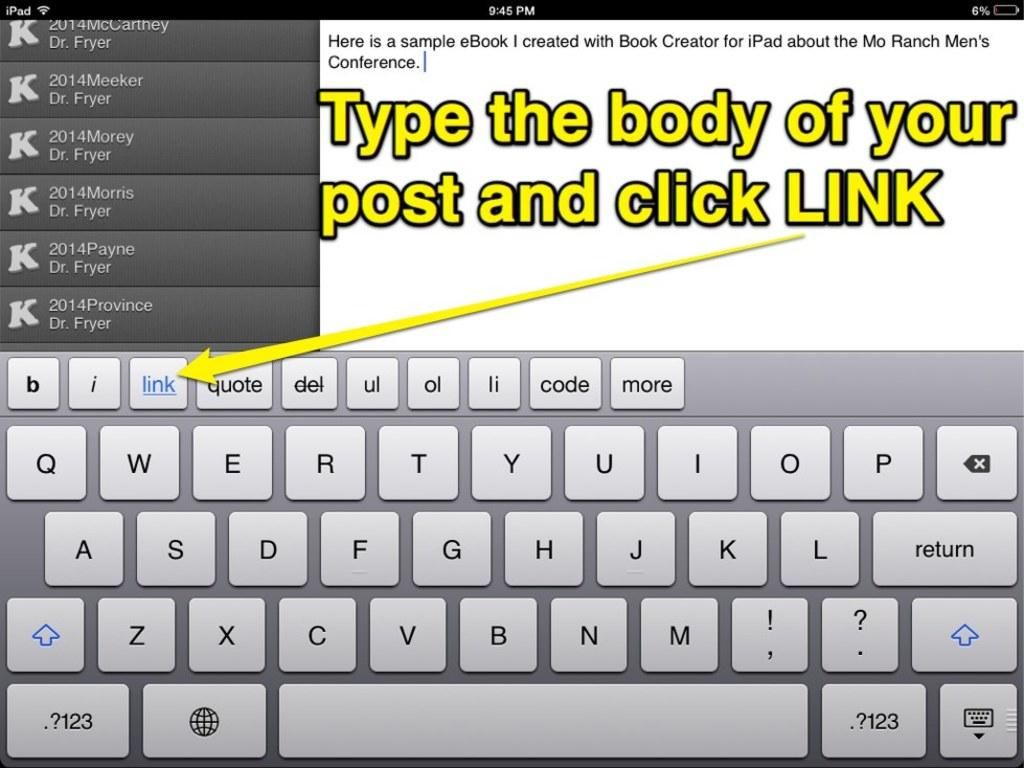<image>
Describe the image concisely. Yellow text explains where to click the link. 